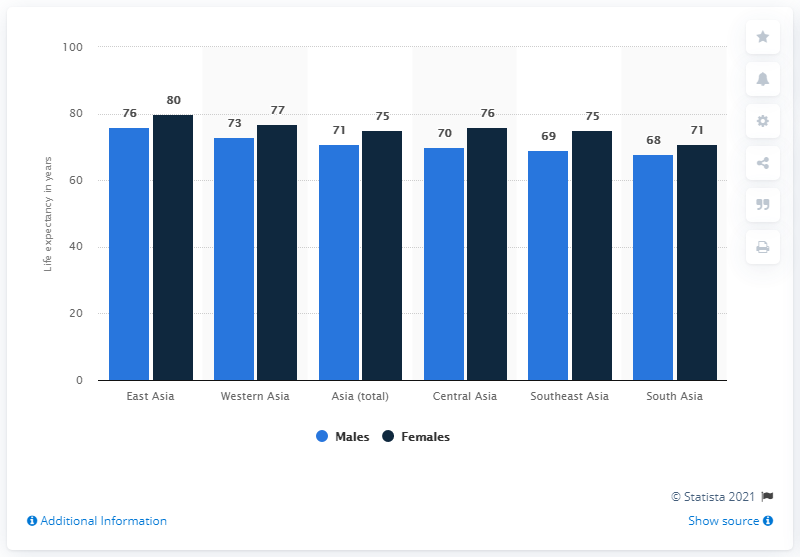Identify some key points in this picture. The difference between the leftmost and rightmost values in the graph is 5. The smallest difference in average life expectancy between the two genders can be found in South Asia. 